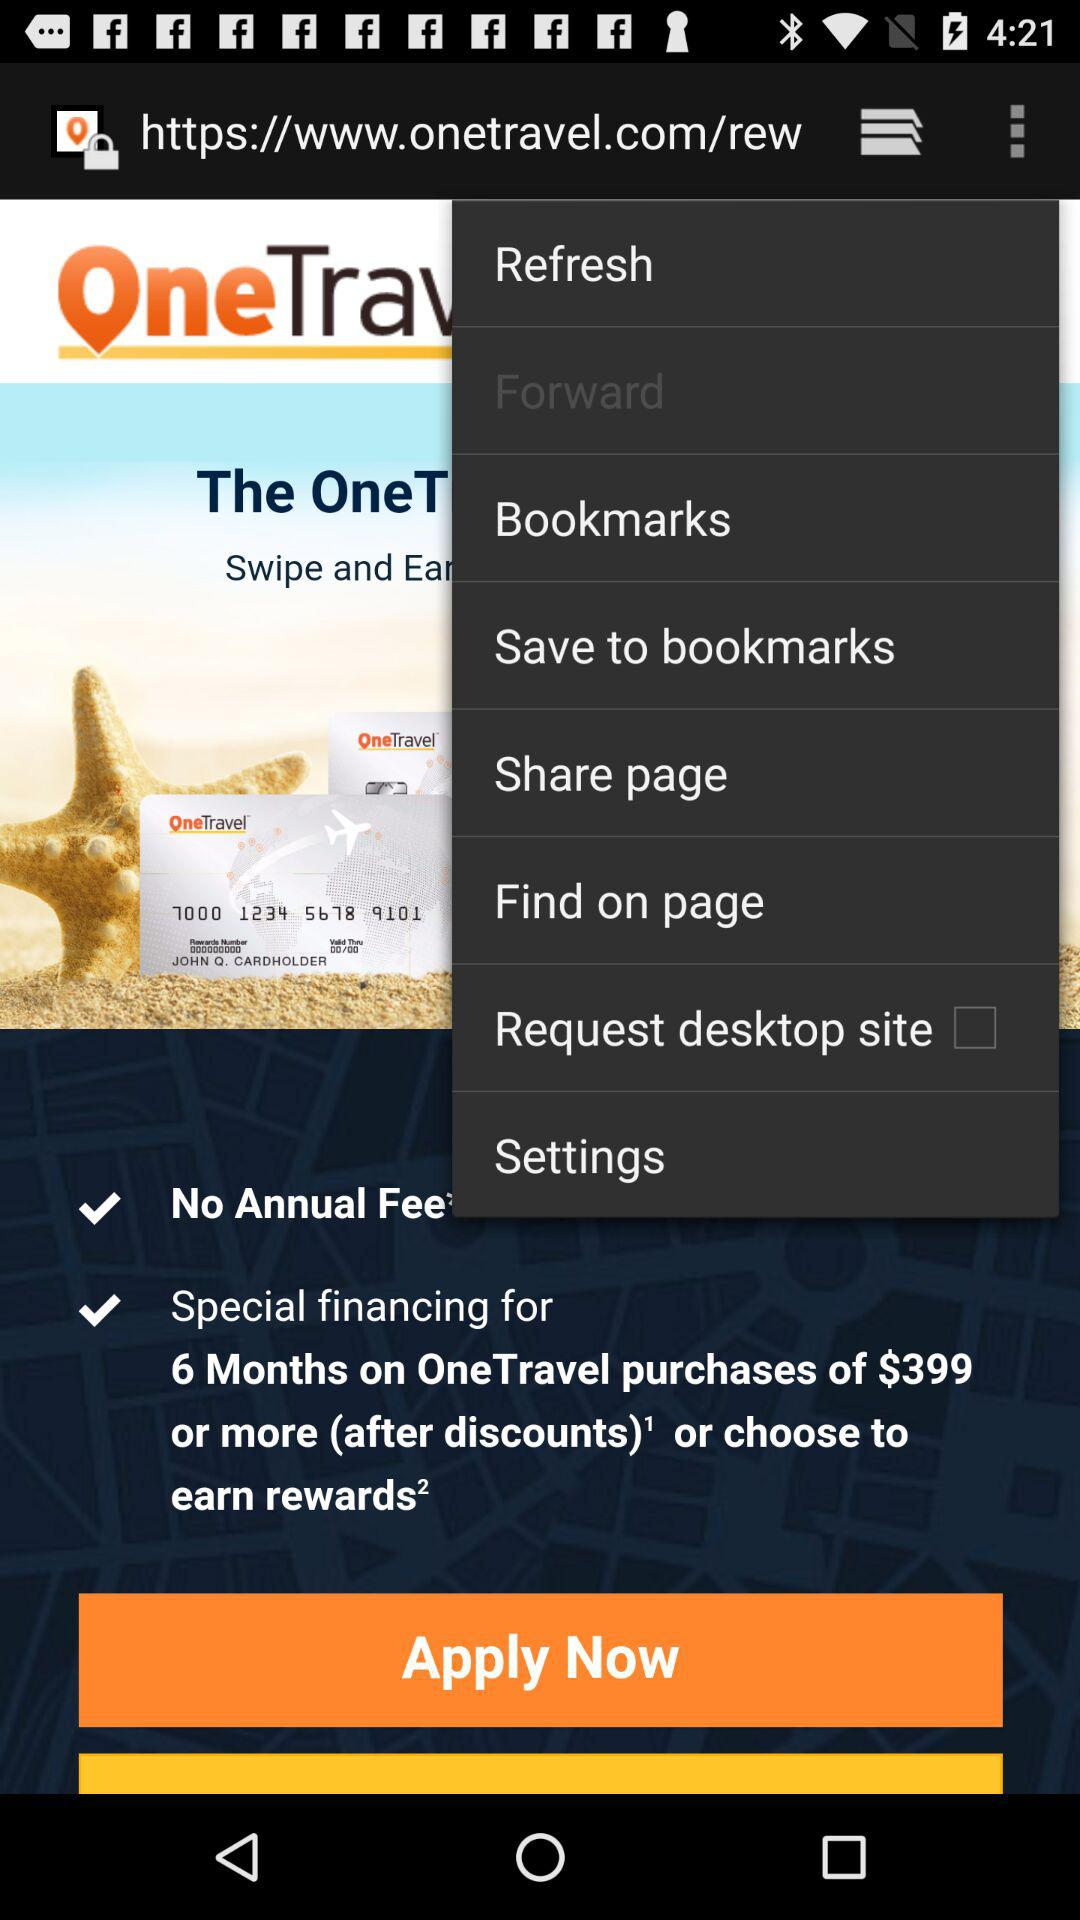What is the name of the application? The application is "OneTravel". 